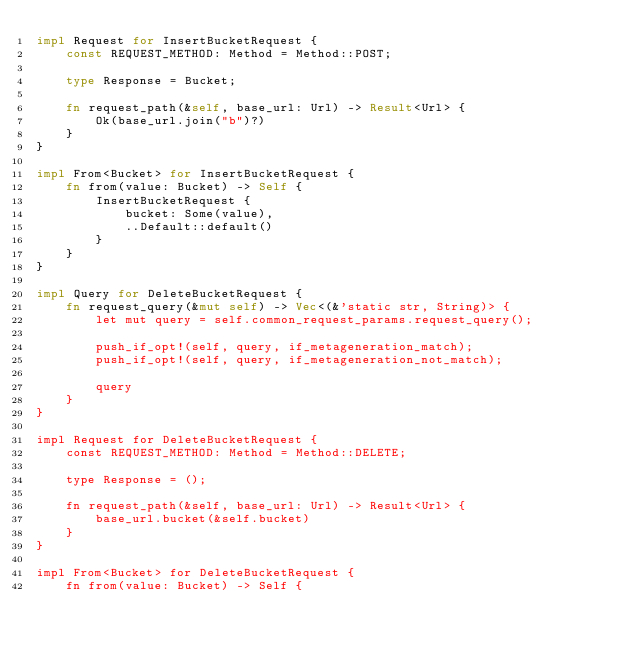Convert code to text. <code><loc_0><loc_0><loc_500><loc_500><_Rust_>impl Request for InsertBucketRequest {
    const REQUEST_METHOD: Method = Method::POST;

    type Response = Bucket;

    fn request_path(&self, base_url: Url) -> Result<Url> {
        Ok(base_url.join("b")?)
    }
}

impl From<Bucket> for InsertBucketRequest {
    fn from(value: Bucket) -> Self {
        InsertBucketRequest {
            bucket: Some(value),
            ..Default::default()
        }
    }
}

impl Query for DeleteBucketRequest {
    fn request_query(&mut self) -> Vec<(&'static str, String)> {
        let mut query = self.common_request_params.request_query();

        push_if_opt!(self, query, if_metageneration_match);
        push_if_opt!(self, query, if_metageneration_not_match);

        query
    }
}

impl Request for DeleteBucketRequest {
    const REQUEST_METHOD: Method = Method::DELETE;

    type Response = ();

    fn request_path(&self, base_url: Url) -> Result<Url> {
        base_url.bucket(&self.bucket)
    }
}

impl From<Bucket> for DeleteBucketRequest {
    fn from(value: Bucket) -> Self {</code> 